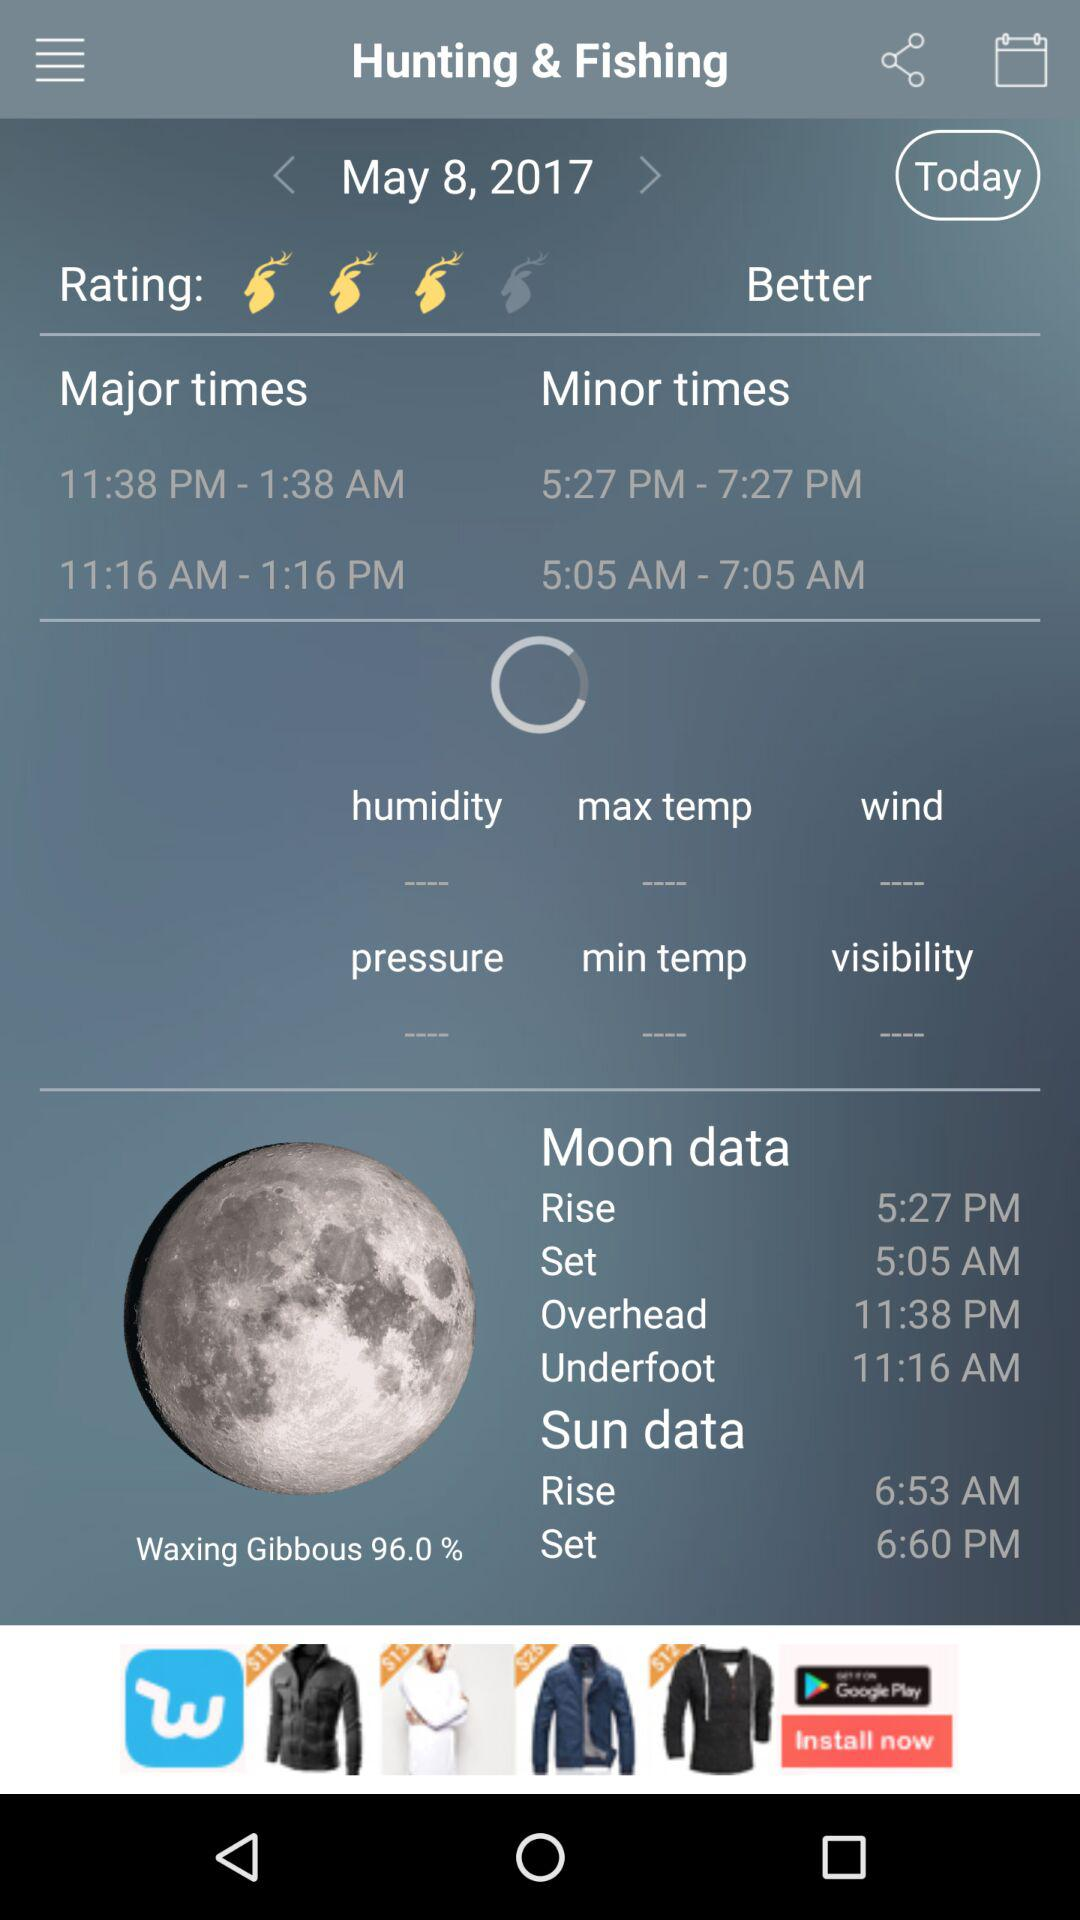What time of day does the moon have underfoot? The time of day when the moon is underfoot is 11:16 AM. 